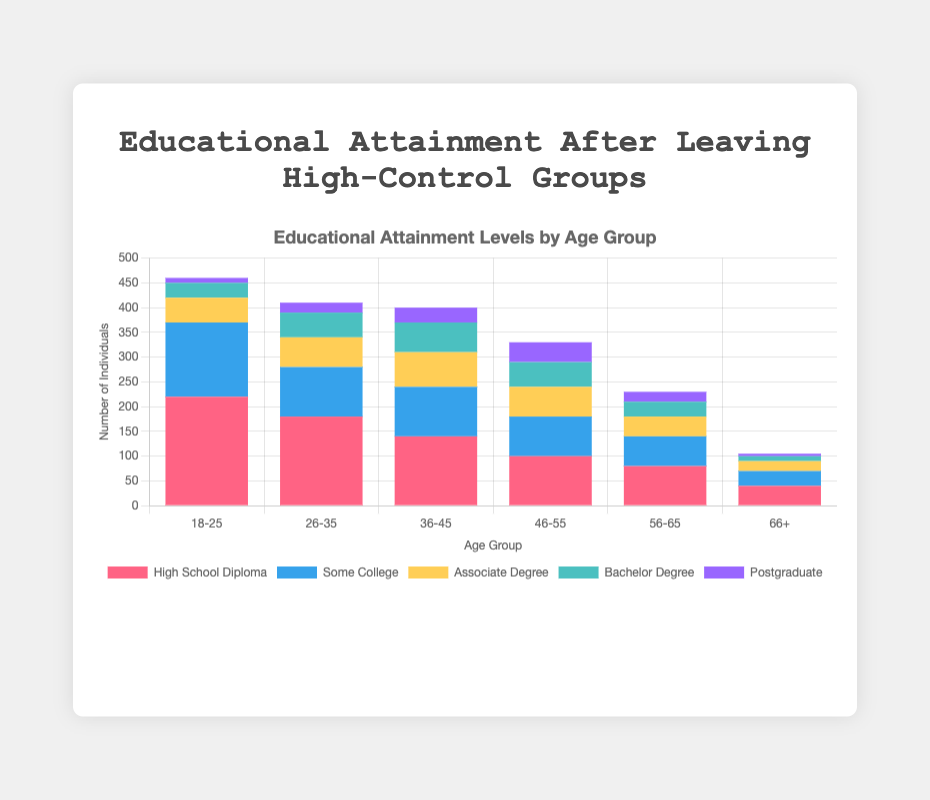Which age group has the highest number of individuals with a High School Diploma? By observing the stacked bar chart, the 18-25 age group has the tallest red section, indicating the highest number of individuals with a High School Diploma.
Answer: 18-25 How many individuals in the 36-45 age group have a Bachelor's Degree and a Postgraduate degree combined? Add the numbers for Bachelor Degree (60) and Postgraduate (30) for the 36-45 age group, which gives 60 + 30 = 90.
Answer: 90 What is the total number of individuals with an Associate Degree across all age groups? Sum the Associate Degree numbers for all age groups: 50 + 60 + 70 + 60 + 40 + 20 = 300.
Answer: 300 Which age group has the smallest number of individuals with Some College education? The 66+ age group has the smallest blue section, indicating the smallest number of individuals with Some College education (30).
Answer: 66+ In which age group is the ratio of individuals with a Bachelor’s Degree to those with Some College highest? Calculate the ratio for each age group. The highest ratio is found by comparing each ratio:
18-25: 30/150, 26-35: 50/100, 36-45: 60/100, 46-55: 50/80, 56-65: 30/60, 66+: 10/30. 
The highest ratio is for the 46-55 age group (50/80 = 0.625).
Answer: 46-55 Which color represents the Postgraduate level in the chart? Observing the legend, the Postgraduate level is represented by the purple color.
Answer: Purple How does the number of individuals with High School Diplomas change as age increases? The number of individuals with High School Diplomas decreases consistently from the 18-25 age group to the 66+ age group.
Answer: Decreases Compare the number of individuals with Bachelor Degrees between the 26-35 and 56-65 age groups. Which group has more? The 26-35 age group has 50 individuals with a Bachelor's Degree, whereas the 56-65 age group has 30 individuals with a Bachelor's Degree. So, 26-35 has more.
Answer: 26-35 What is the difference in the number of individuals with a High School Diploma between the 18-25 and 56-65 age groups? Subtract the number of individuals with a High School Diploma in the 56-65 age group (80) from the number in the 18-25 age group (220), which gives 220 - 80 = 140.
Answer: 140 What's the average number of individuals with Some College education across all age groups? Sum the numbers for Some College across all age groups and divide by the number of age groups: (150 + 100 + 100 + 80 + 60 + 30) / 6 = 520 / 6 ≈ 87.
Answer: 87 